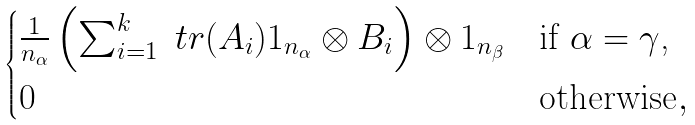Convert formula to latex. <formula><loc_0><loc_0><loc_500><loc_500>\begin{cases} \frac { 1 } { n _ { \alpha } } \left ( \sum _ { i = 1 } ^ { k } \ t r ( A _ { i } ) 1 _ { n _ { \alpha } } \otimes B _ { i } \right ) \otimes 1 _ { n _ { \beta } } & \text {if $\alpha = \gamma$,} \\ 0 & \text {otherwise} , \end{cases}</formula> 